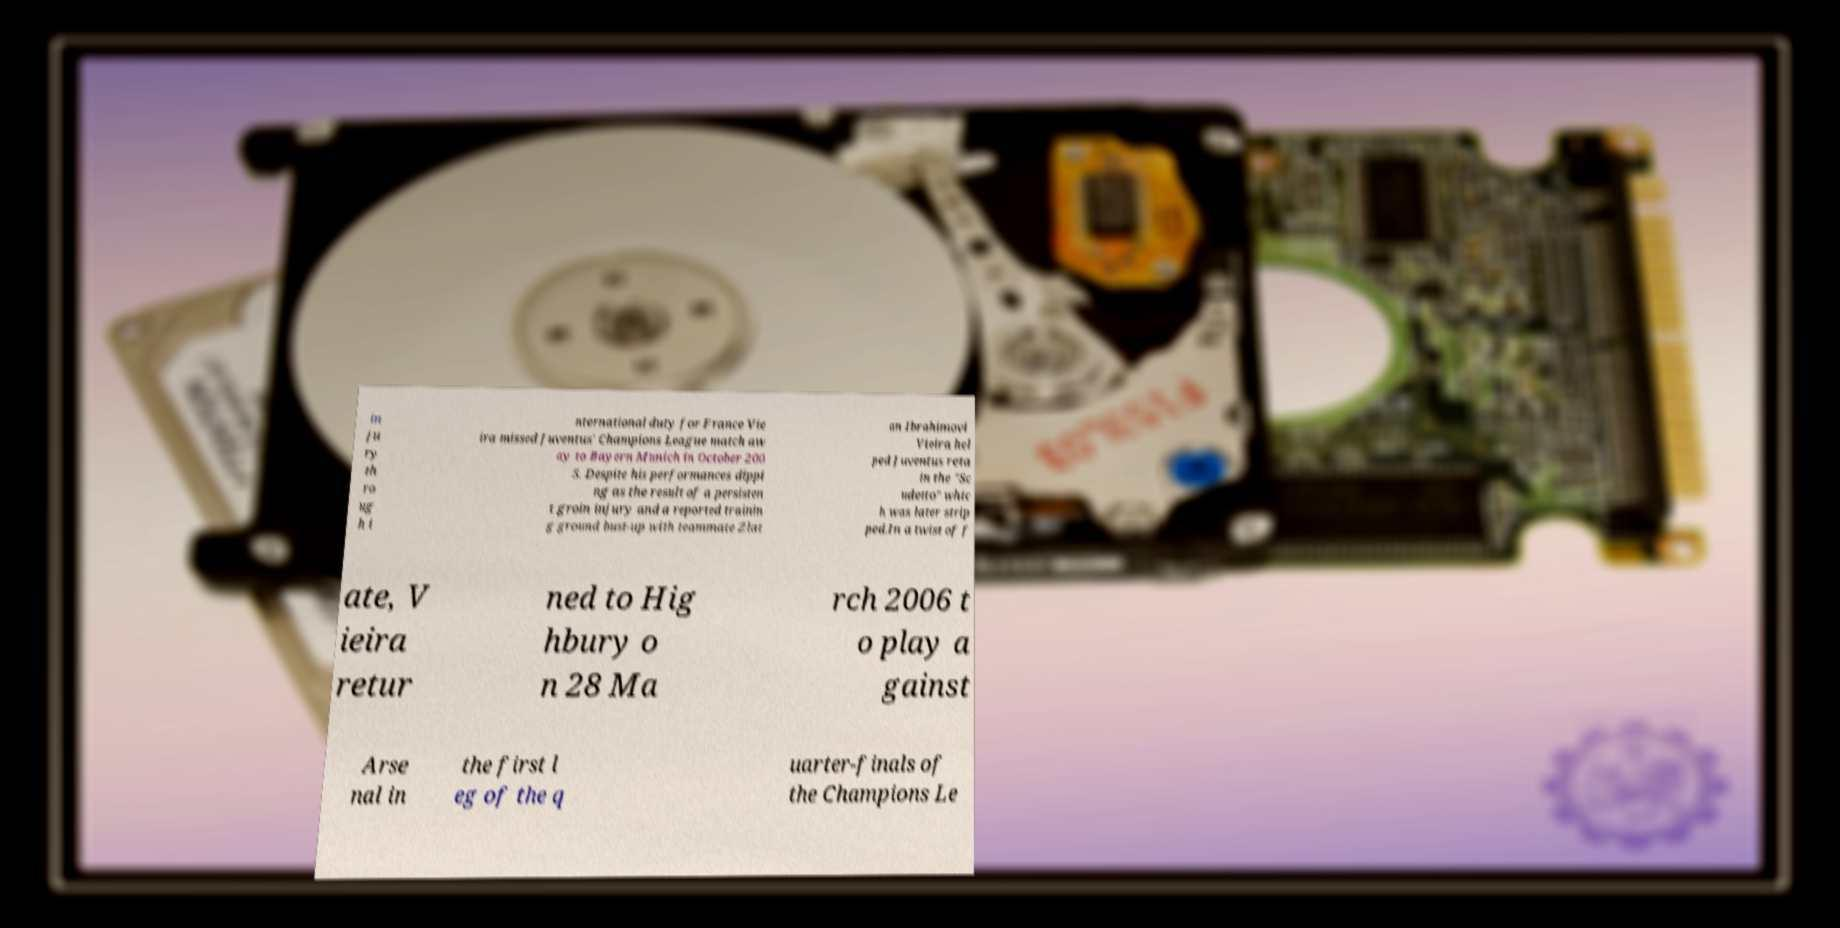For documentation purposes, I need the text within this image transcribed. Could you provide that? in ju ry th ro ug h i nternational duty for France Vie ira missed Juventus' Champions League match aw ay to Bayern Munich in October 200 5. Despite his performances dippi ng as the result of a persisten t groin injury and a reported trainin g ground bust-up with teammate Zlat an Ibrahimovi Vieira hel ped Juventus reta in the "Sc udetto" whic h was later strip ped.In a twist of f ate, V ieira retur ned to Hig hbury o n 28 Ma rch 2006 t o play a gainst Arse nal in the first l eg of the q uarter-finals of the Champions Le 